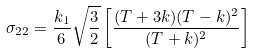Convert formula to latex. <formula><loc_0><loc_0><loc_500><loc_500>\sigma _ { 2 2 } = \frac { k _ { 1 } } { 6 } \sqrt { \frac { 3 } { 2 } } \left [ \frac { ( T + 3 k ) ( T - k ) ^ { 2 } } { ( T + k ) ^ { 2 } } \right ]</formula> 